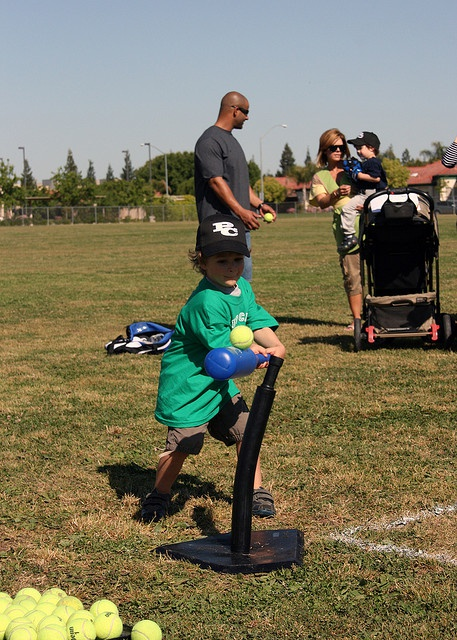Describe the objects in this image and their specific colors. I can see people in darkgray, black, turquoise, and teal tones, people in darkgray, gray, black, and brown tones, people in darkgray, black, gray, and maroon tones, people in darkgray, black, tan, and lightgray tones, and sports ball in darkgray, khaki, and olive tones in this image. 